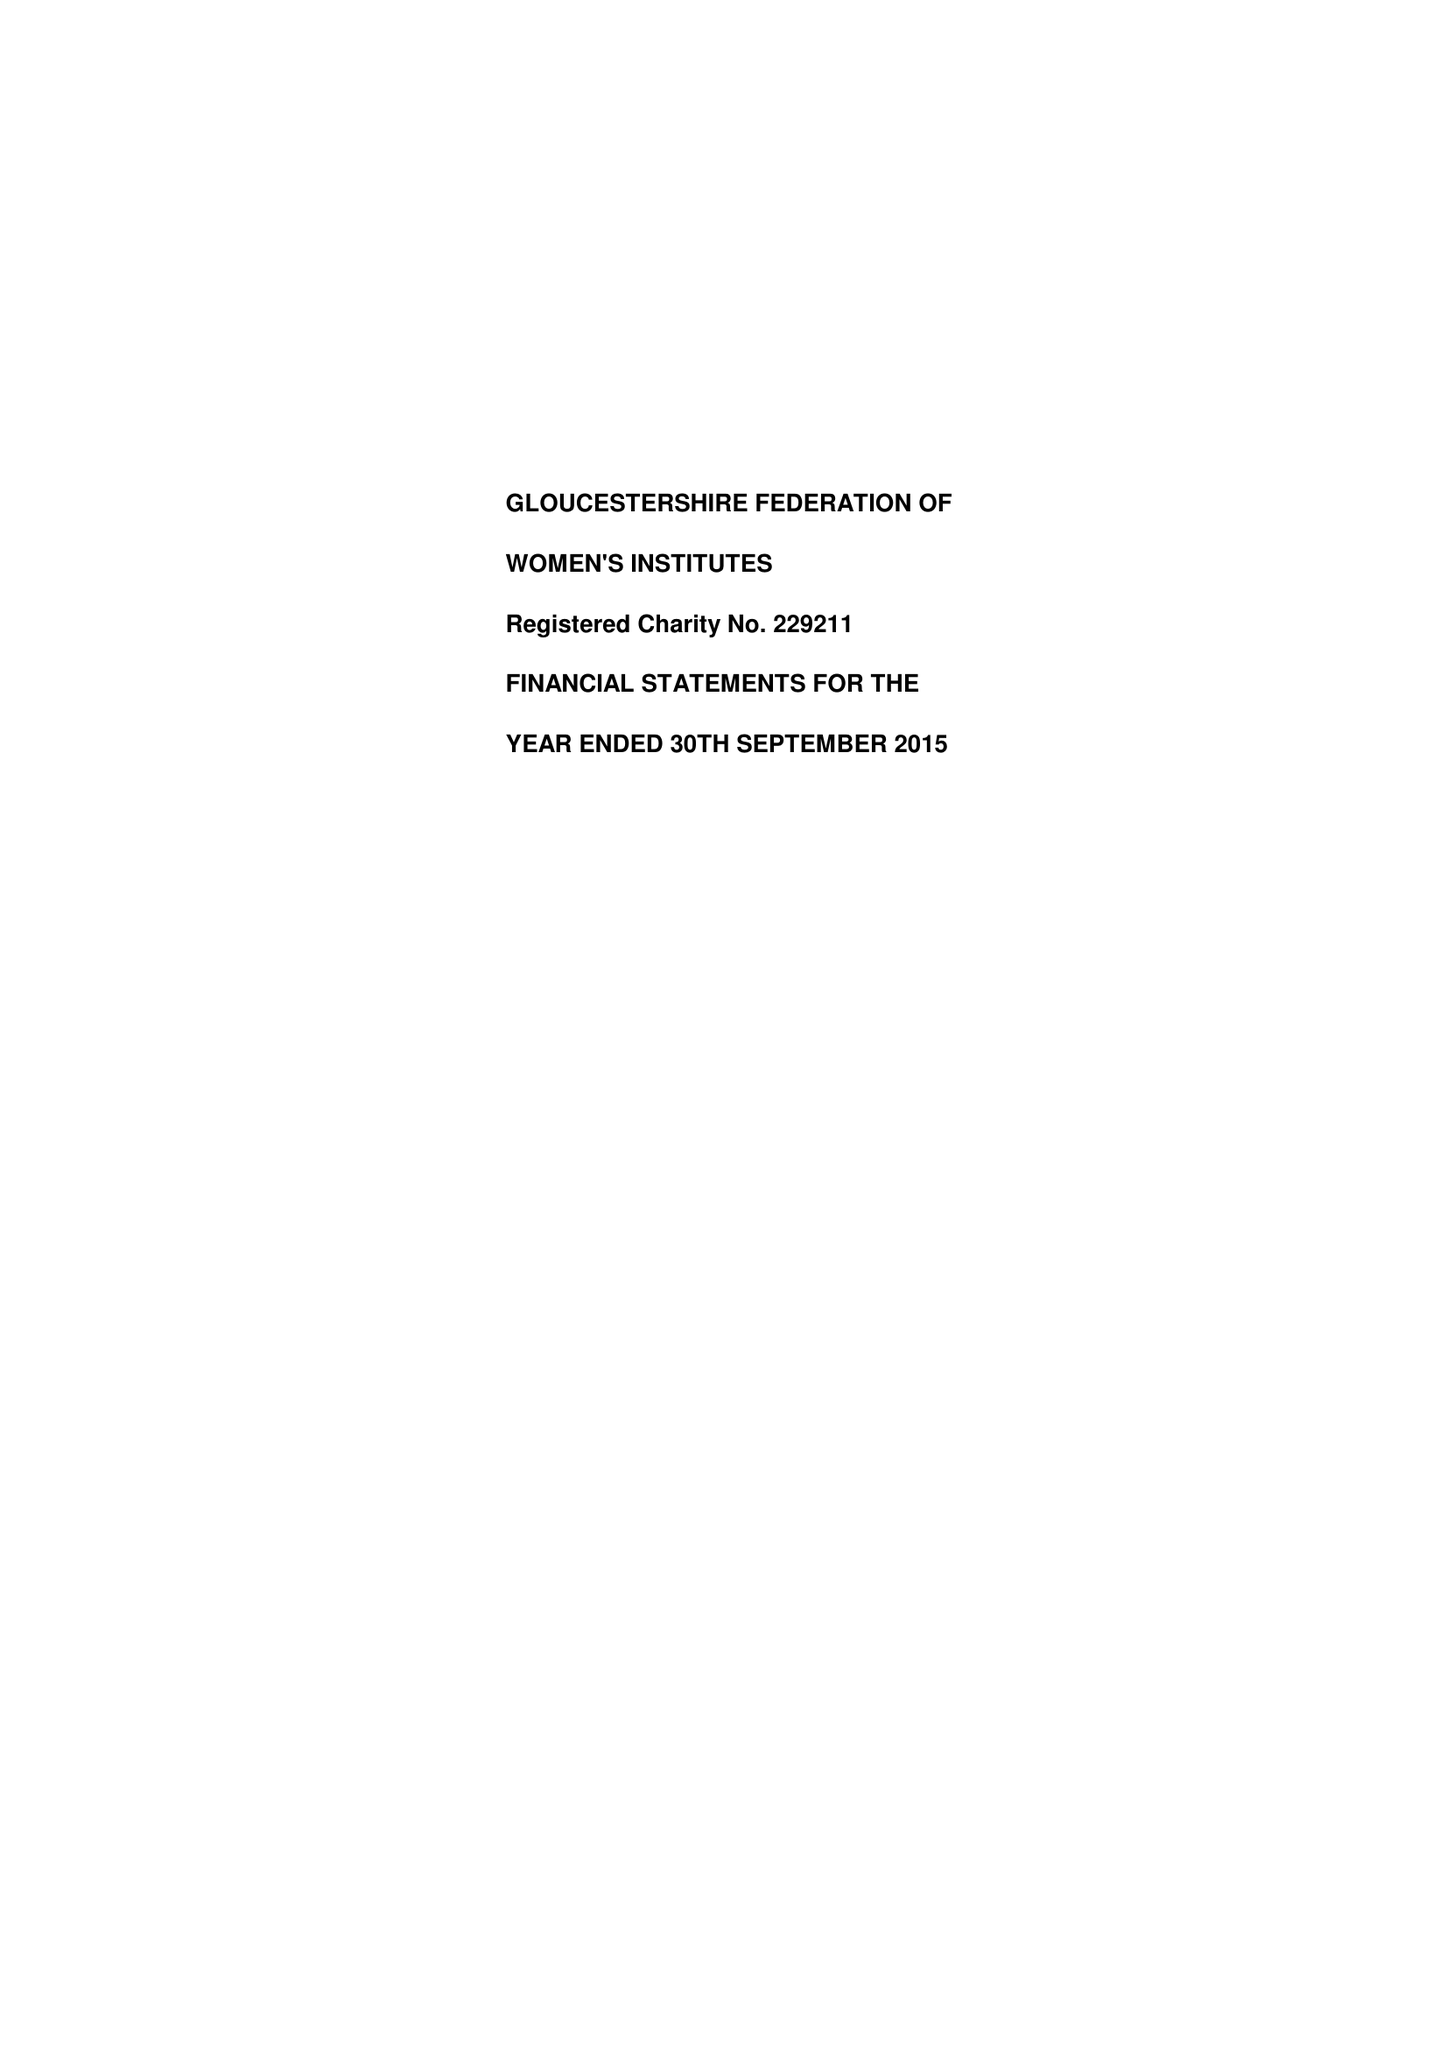What is the value for the address__street_line?
Answer the question using a single word or phrase. 2 BRUNSWICK SQUARE 